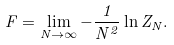<formula> <loc_0><loc_0><loc_500><loc_500>F = \lim _ { N \to \infty } - \frac { 1 } { N ^ { 2 } } \ln Z _ { N } .</formula> 